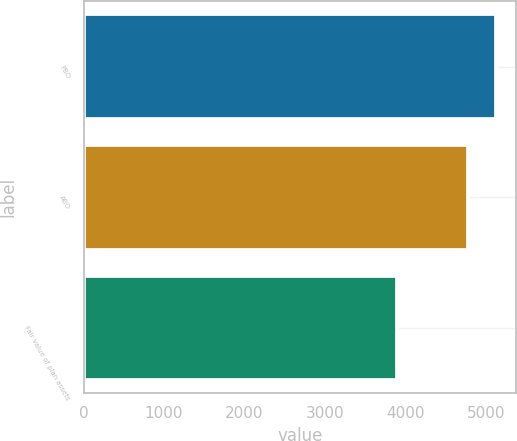Convert chart to OTSL. <chart><loc_0><loc_0><loc_500><loc_500><bar_chart><fcel>PBO<fcel>ABO<fcel>Fair value of plan assets<nl><fcel>5120.3<fcel>4780.4<fcel>3890<nl></chart> 